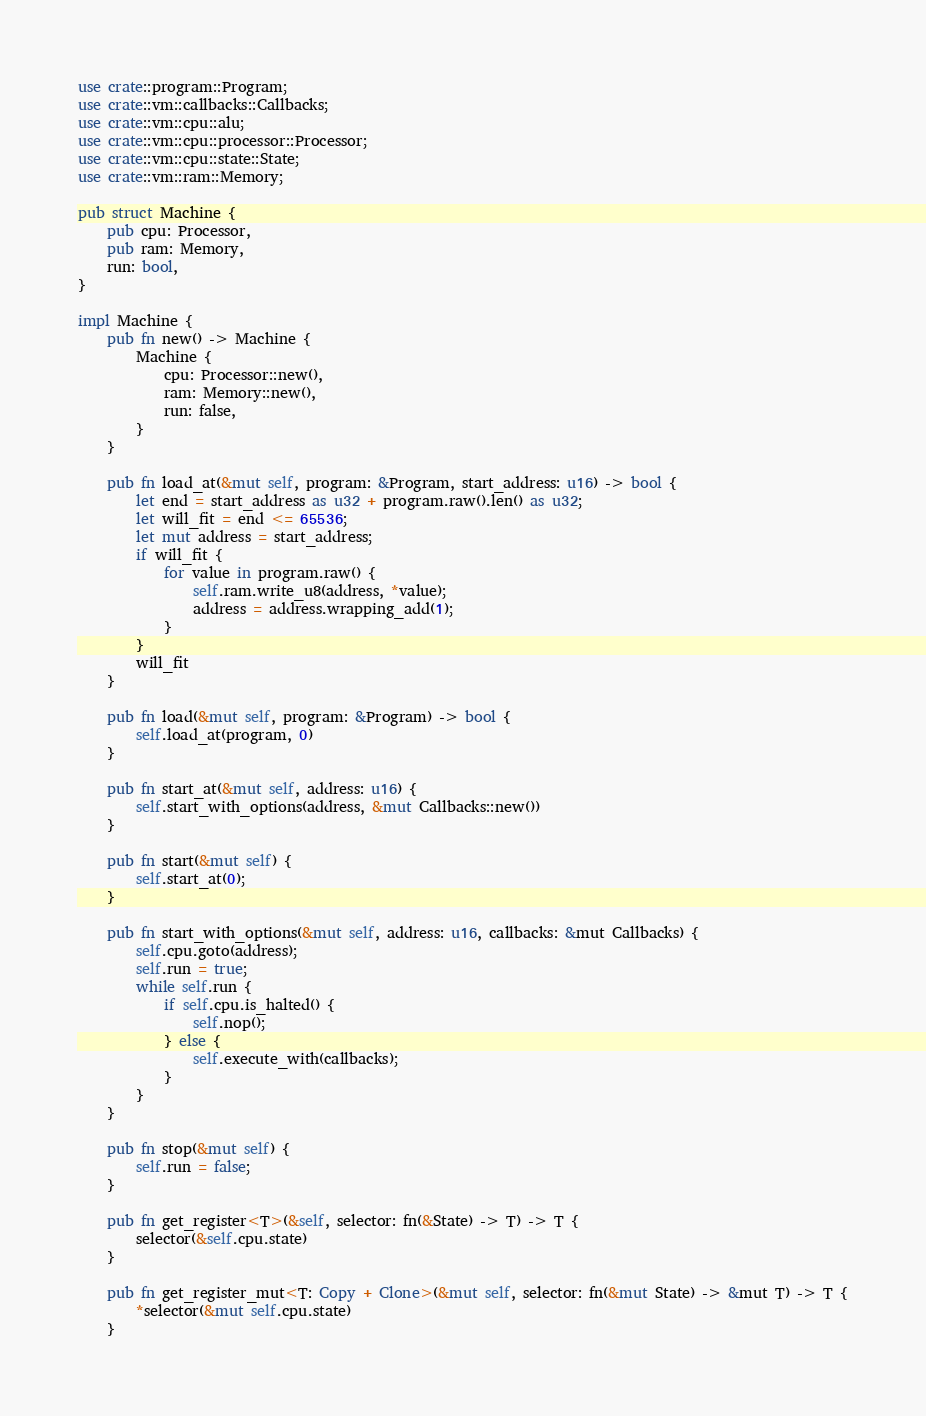Convert code to text. <code><loc_0><loc_0><loc_500><loc_500><_Rust_>use crate::program::Program;
use crate::vm::callbacks::Callbacks;
use crate::vm::cpu::alu;
use crate::vm::cpu::processor::Processor;
use crate::vm::cpu::state::State;
use crate::vm::ram::Memory;

pub struct Machine {
    pub cpu: Processor,
    pub ram: Memory,
    run: bool,
}

impl Machine {
    pub fn new() -> Machine {
        Machine {
            cpu: Processor::new(),
            ram: Memory::new(),
            run: false,
        }
    }

    pub fn load_at(&mut self, program: &Program, start_address: u16) -> bool {
        let end = start_address as u32 + program.raw().len() as u32;
        let will_fit = end <= 65536;
        let mut address = start_address;
        if will_fit {
            for value in program.raw() {
                self.ram.write_u8(address, *value);
                address = address.wrapping_add(1);
            }
        }
        will_fit
    }

    pub fn load(&mut self, program: &Program) -> bool {
        self.load_at(program, 0)
    }

    pub fn start_at(&mut self, address: u16) {
        self.start_with_options(address, &mut Callbacks::new())
    }

    pub fn start(&mut self) {
        self.start_at(0);
    }

    pub fn start_with_options(&mut self, address: u16, callbacks: &mut Callbacks) {
        self.cpu.goto(address);
        self.run = true;
        while self.run {
            if self.cpu.is_halted() {
                self.nop();
            } else {
                self.execute_with(callbacks);
            }
        }
    }

    pub fn stop(&mut self) {
        self.run = false;
    }

    pub fn get_register<T>(&self, selector: fn(&State) -> T) -> T {
        selector(&self.cpu.state)
    }

    pub fn get_register_mut<T: Copy + Clone>(&mut self, selector: fn(&mut State) -> &mut T) -> T {
        *selector(&mut self.cpu.state)
    }
</code> 